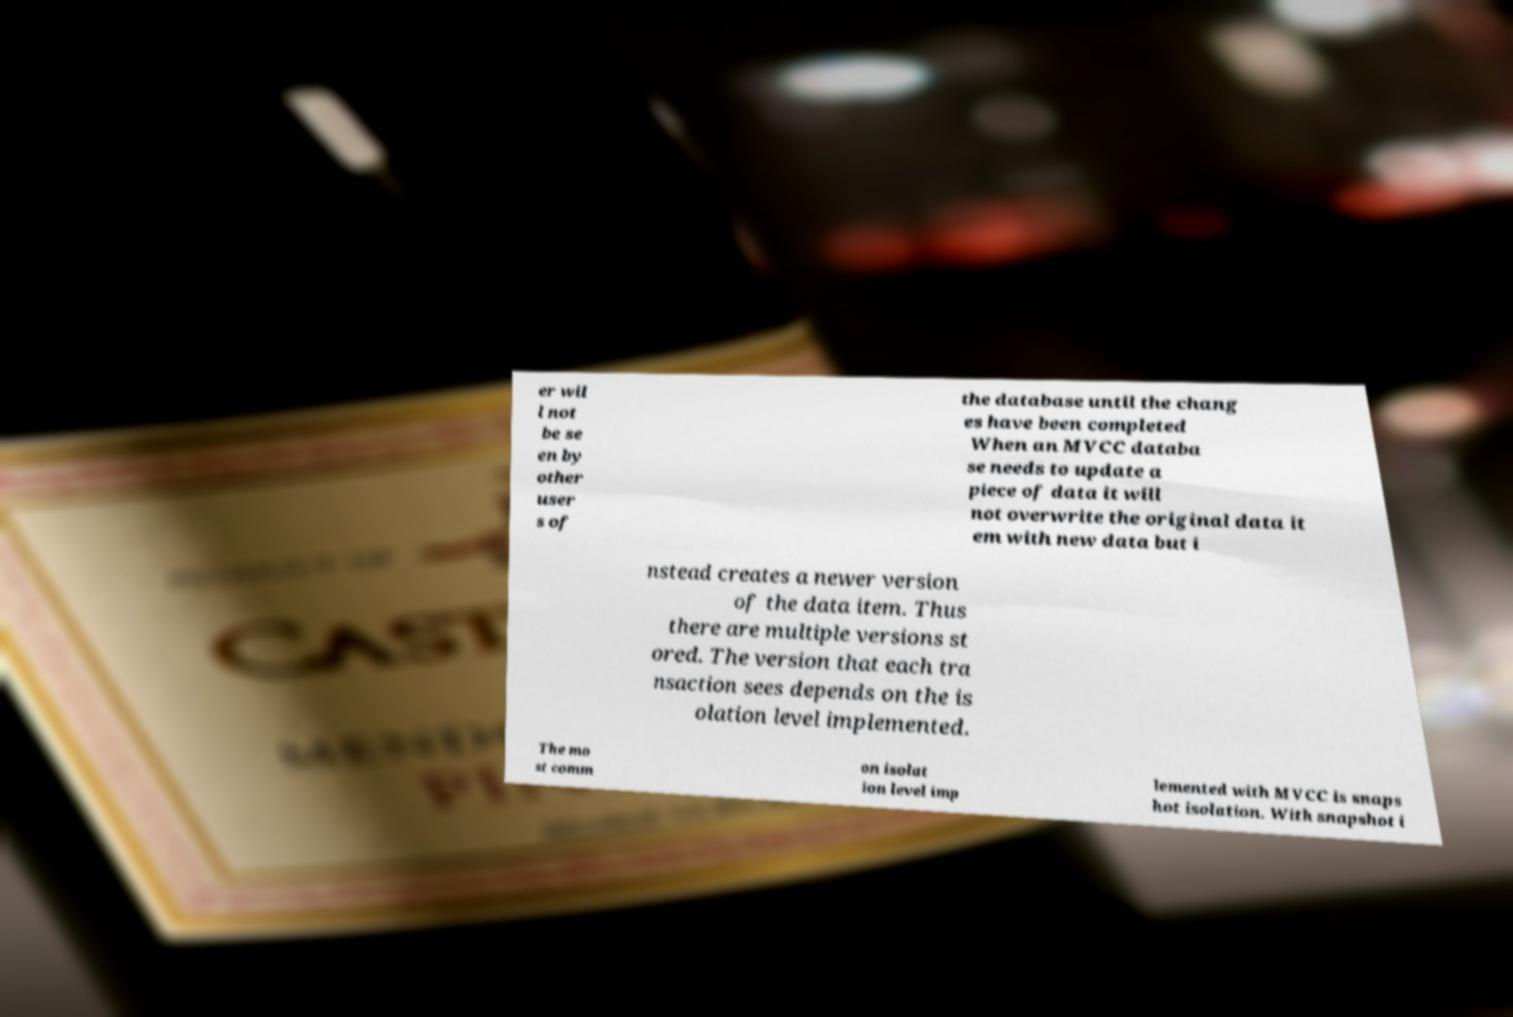For documentation purposes, I need the text within this image transcribed. Could you provide that? er wil l not be se en by other user s of the database until the chang es have been completed When an MVCC databa se needs to update a piece of data it will not overwrite the original data it em with new data but i nstead creates a newer version of the data item. Thus there are multiple versions st ored. The version that each tra nsaction sees depends on the is olation level implemented. The mo st comm on isolat ion level imp lemented with MVCC is snaps hot isolation. With snapshot i 